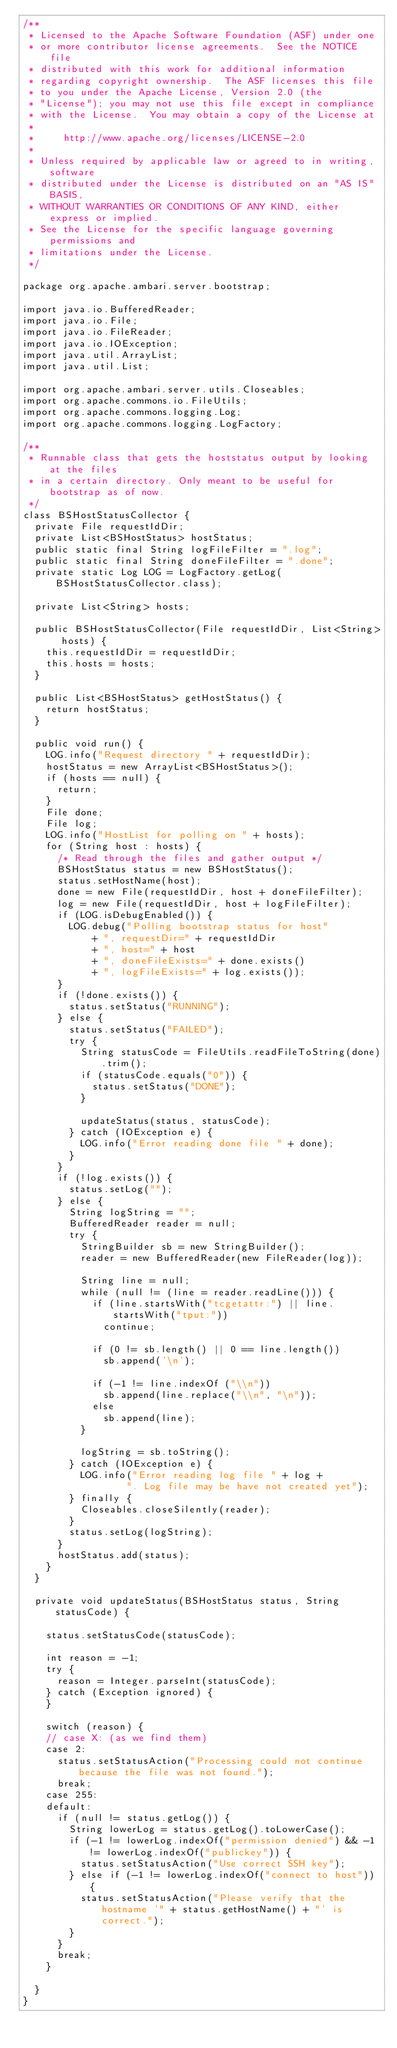<code> <loc_0><loc_0><loc_500><loc_500><_Java_>/**
 * Licensed to the Apache Software Foundation (ASF) under one
 * or more contributor license agreements.  See the NOTICE file
 * distributed with this work for additional information
 * regarding copyright ownership.  The ASF licenses this file
 * to you under the Apache License, Version 2.0 (the
 * "License"); you may not use this file except in compliance
 * with the License.  You may obtain a copy of the License at
 *
 *     http://www.apache.org/licenses/LICENSE-2.0
 *
 * Unless required by applicable law or agreed to in writing, software
 * distributed under the License is distributed on an "AS IS" BASIS,
 * WITHOUT WARRANTIES OR CONDITIONS OF ANY KIND, either express or implied.
 * See the License for the specific language governing permissions and
 * limitations under the License.
 */

package org.apache.ambari.server.bootstrap;

import java.io.BufferedReader;
import java.io.File;
import java.io.FileReader;
import java.io.IOException;
import java.util.ArrayList;
import java.util.List;

import org.apache.ambari.server.utils.Closeables;
import org.apache.commons.io.FileUtils;
import org.apache.commons.logging.Log;
import org.apache.commons.logging.LogFactory;

/**
 * Runnable class that gets the hoststatus output by looking at the files
 * in a certain directory. Only meant to be useful for bootstrap as of now.
 */
class BSHostStatusCollector {
  private File requestIdDir;
  private List<BSHostStatus> hostStatus;
  public static final String logFileFilter = ".log";
  public static final String doneFileFilter = ".done";
  private static Log LOG = LogFactory.getLog(BSHostStatusCollector.class);

  private List<String> hosts;

  public BSHostStatusCollector(File requestIdDir, List<String> hosts) {
    this.requestIdDir = requestIdDir;
    this.hosts = hosts;
  }

  public List<BSHostStatus> getHostStatus() {
    return hostStatus;
  }

  public void run() {
    LOG.info("Request directory " + requestIdDir);
    hostStatus = new ArrayList<BSHostStatus>();
    if (hosts == null) {
      return;
    }
    File done;
    File log;
    LOG.info("HostList for polling on " + hosts);
    for (String host : hosts) {
      /* Read through the files and gather output */
      BSHostStatus status = new BSHostStatus();
      status.setHostName(host);
      done = new File(requestIdDir, host + doneFileFilter);
      log = new File(requestIdDir, host + logFileFilter);
      if (LOG.isDebugEnabled()) {
        LOG.debug("Polling bootstrap status for host"
            + ", requestDir=" + requestIdDir
            + ", host=" + host
            + ", doneFileExists=" + done.exists()
            + ", logFileExists=" + log.exists());
      }
      if (!done.exists()) {
        status.setStatus("RUNNING");
      } else {
        status.setStatus("FAILED");
        try {
          String statusCode = FileUtils.readFileToString(done).trim();
          if (statusCode.equals("0")) {
            status.setStatus("DONE");
          }
          
          updateStatus(status, statusCode);
        } catch (IOException e) {
          LOG.info("Error reading done file " + done);
        }
      }
      if (!log.exists()) {
        status.setLog("");
      } else {
        String logString = "";
        BufferedReader reader = null;
        try {
          StringBuilder sb = new StringBuilder();
          reader = new BufferedReader(new FileReader(log));

          String line = null;
          while (null != (line = reader.readLine())) {
            if (line.startsWith("tcgetattr:") || line.startsWith("tput:"))
              continue;

            if (0 != sb.length() || 0 == line.length())
              sb.append('\n');

            if (-1 != line.indexOf ("\\n"))
              sb.append(line.replace("\\n", "\n"));
            else
              sb.append(line);
          }
          
          logString = sb.toString();
        } catch (IOException e) {
          LOG.info("Error reading log file " + log +
                  ". Log file may be have not created yet");
        } finally {
          Closeables.closeSilently(reader);
        }
        status.setLog(logString);
      }
      hostStatus.add(status);
    }
  }
  
  private void updateStatus(BSHostStatus status, String statusCode) {
    
    status.setStatusCode(statusCode);
    
    int reason = -1;
    try {
      reason = Integer.parseInt(statusCode);
    } catch (Exception ignored) {
    }
    
    switch (reason) {
    // case X: (as we find them)
    case 2:
      status.setStatusAction("Processing could not continue because the file was not found.");
      break;
    case 255:
    default:
      if (null != status.getLog()) {
        String lowerLog = status.getLog().toLowerCase();
        if (-1 != lowerLog.indexOf("permission denied") && -1 != lowerLog.indexOf("publickey")) {
          status.setStatusAction("Use correct SSH key");
        } else if (-1 != lowerLog.indexOf("connect to host")) {
          status.setStatusAction("Please verify that the hostname '" + status.getHostName() + "' is correct.");
        }
      }
      break;
    }
    
  }
}
</code> 